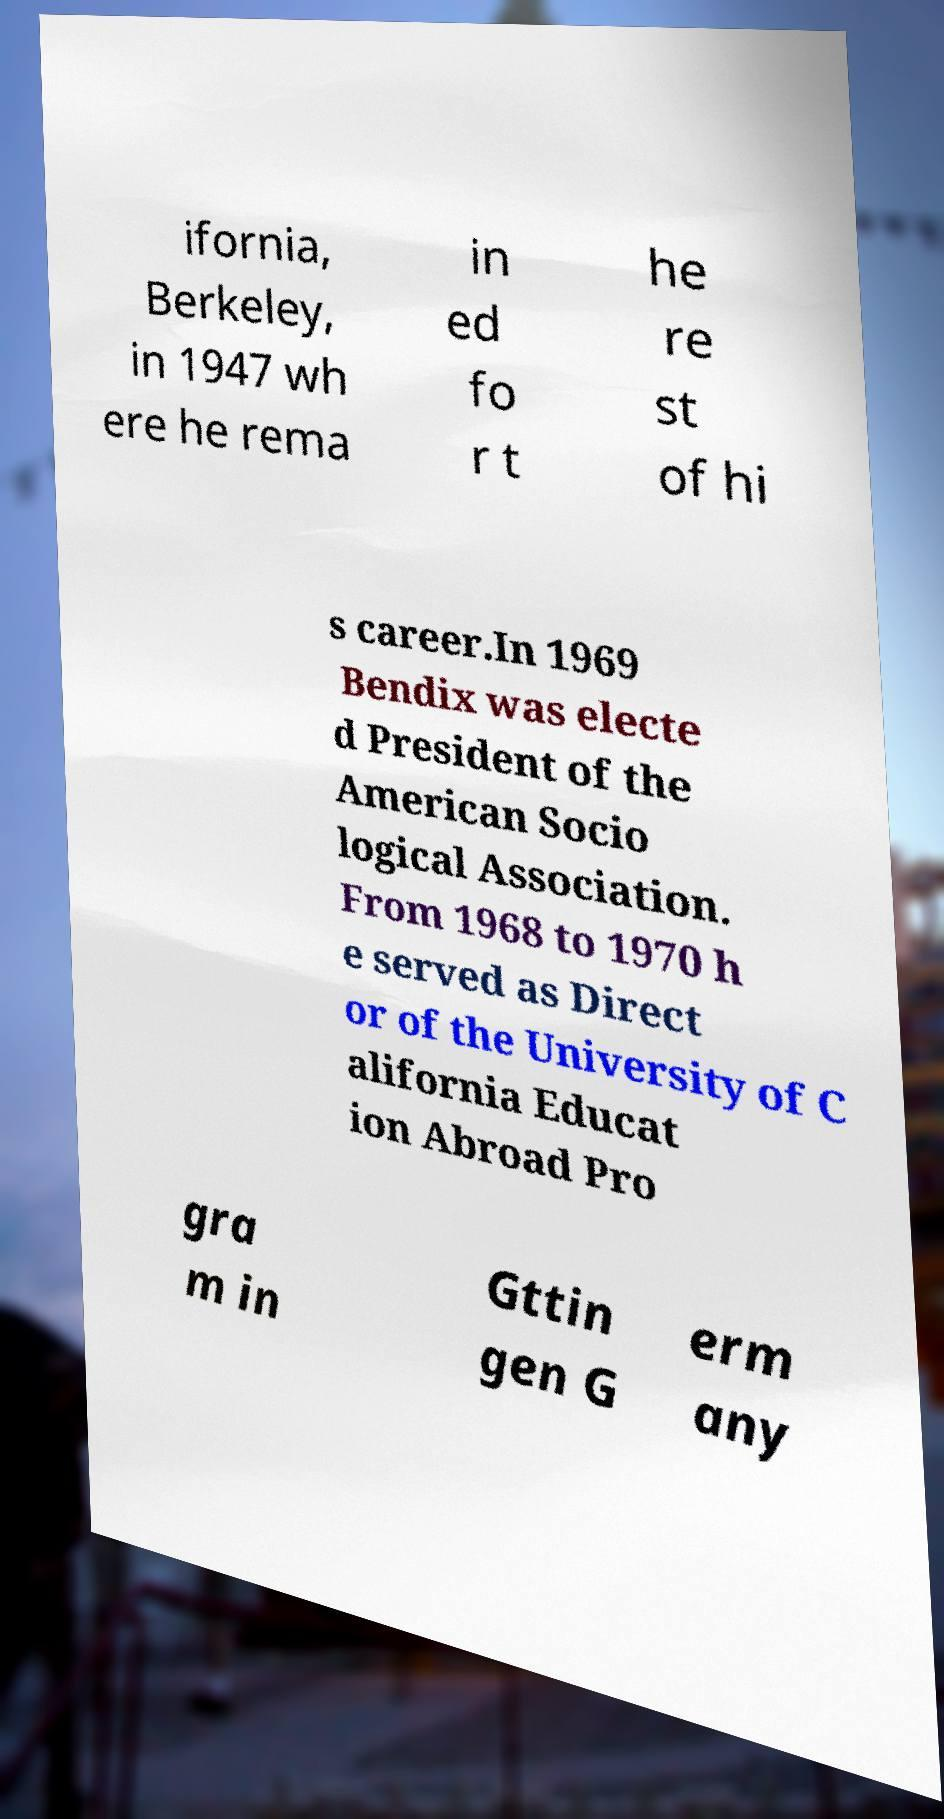What messages or text are displayed in this image? I need them in a readable, typed format. ifornia, Berkeley, in 1947 wh ere he rema in ed fo r t he re st of hi s career.In 1969 Bendix was electe d President of the American Socio logical Association. From 1968 to 1970 h e served as Direct or of the University of C alifornia Educat ion Abroad Pro gra m in Gttin gen G erm any 